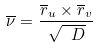<formula> <loc_0><loc_0><loc_500><loc_500>\overline { \nu } = \frac { \overline { r } _ { u } \times \overline { r } _ { v } } { \sqrt { \ D } }</formula> 